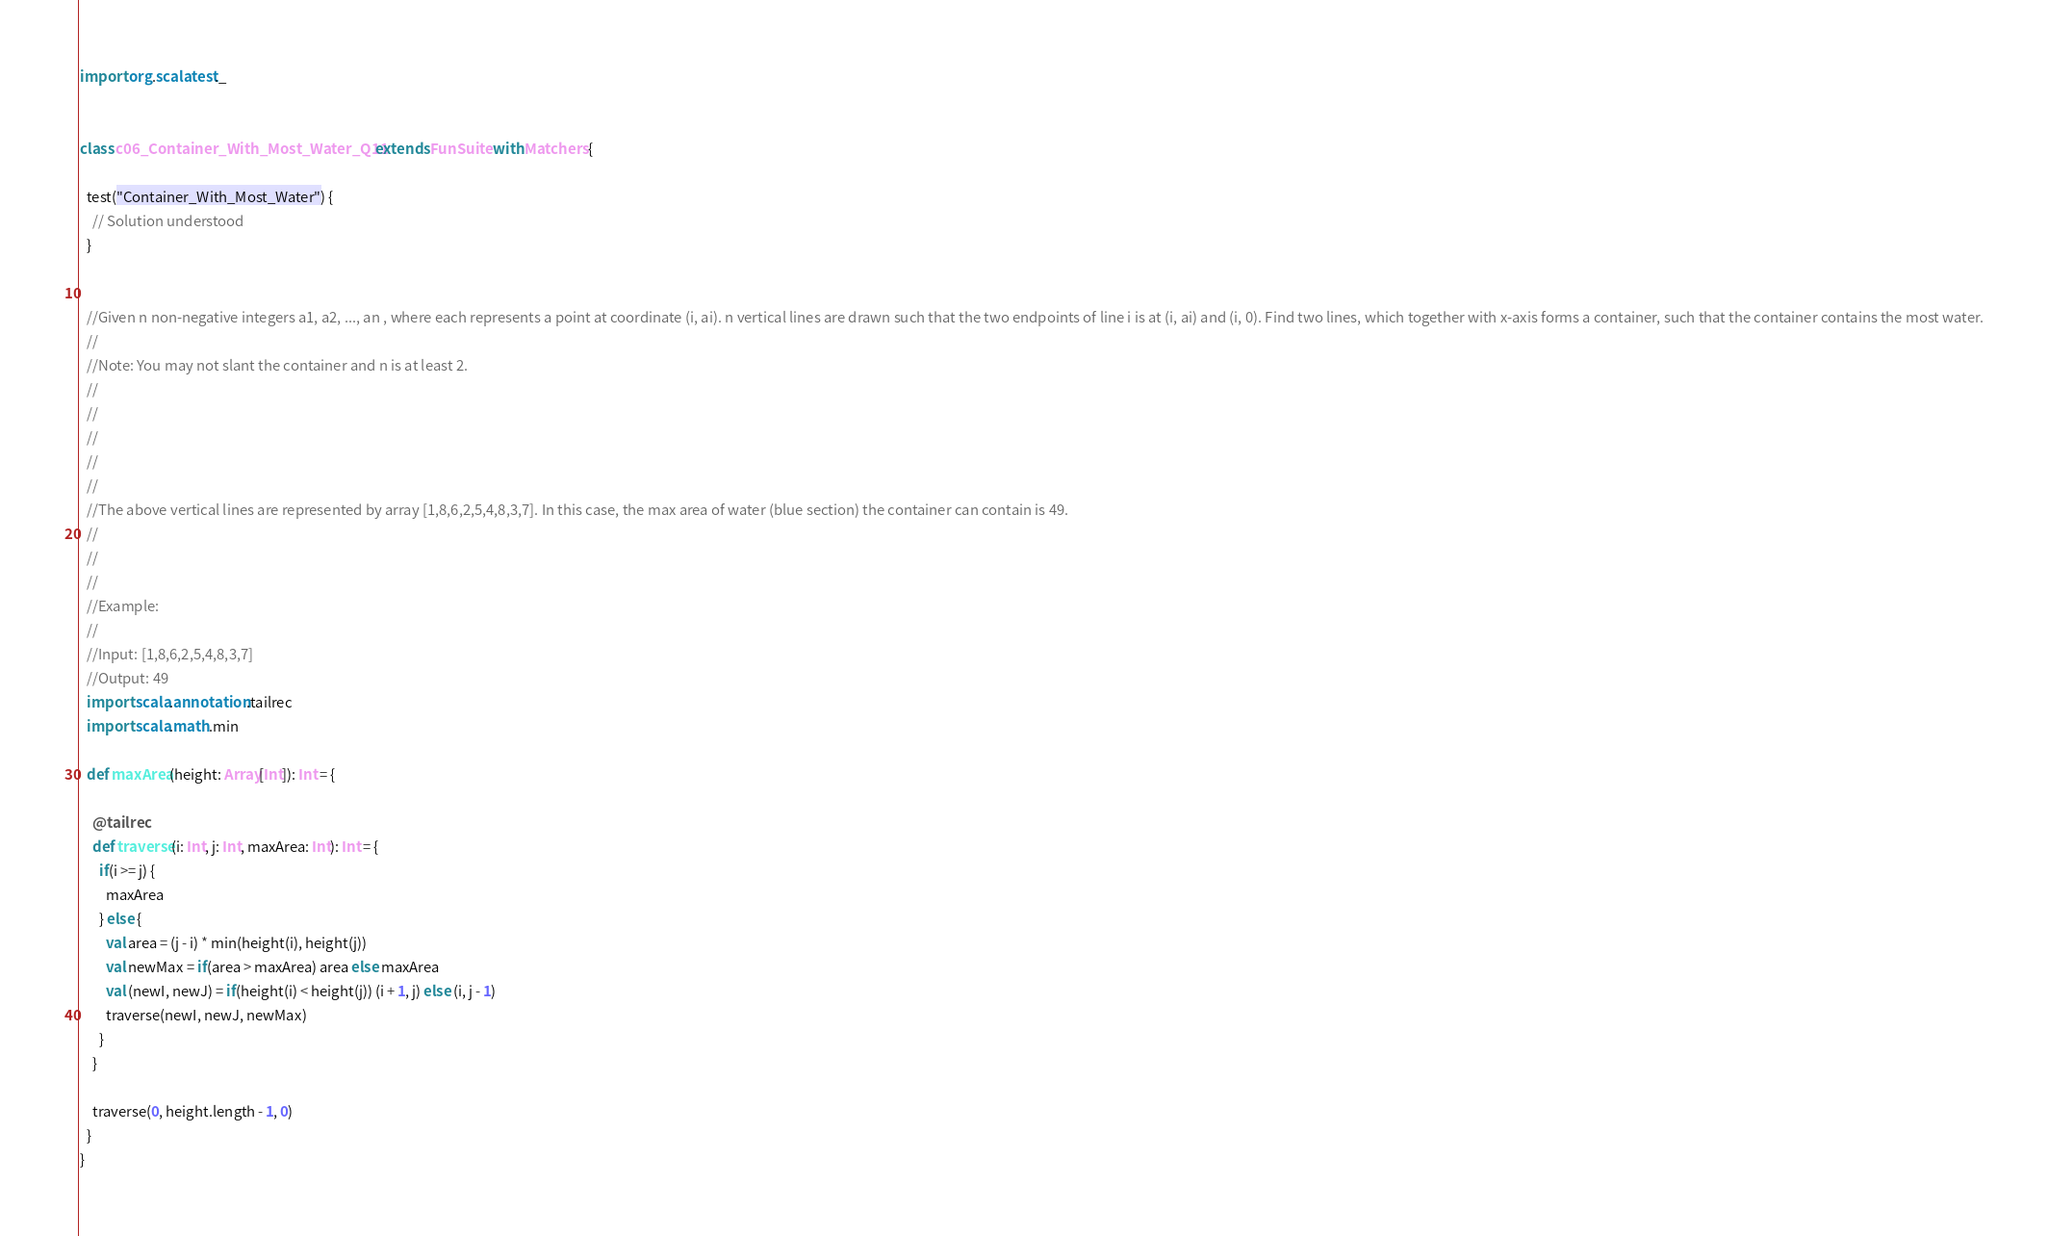<code> <loc_0><loc_0><loc_500><loc_500><_Scala_>
import org.scalatest._


class c06_Container_With_Most_Water_Q11 extends FunSuite with Matchers {

  test("Container_With_Most_Water") {
    // Solution understood
  }


  //Given n non-negative integers a1, a2, ..., an , where each represents a point at coordinate (i, ai). n vertical lines are drawn such that the two endpoints of line i is at (i, ai) and (i, 0). Find two lines, which together with x-axis forms a container, such that the container contains the most water.
  //
  //Note: You may not slant the container and n is at least 2.
  //
  //
  //
  //
  //
  //The above vertical lines are represented by array [1,8,6,2,5,4,8,3,7]. In this case, the max area of water (blue section) the container can contain is 49.
  //
  //
  //
  //Example:
  //
  //Input: [1,8,6,2,5,4,8,3,7]
  //Output: 49
  import scala.annotation.tailrec
  import scala.math.min

  def maxArea(height: Array[Int]): Int = {

    @tailrec
    def traverse(i: Int, j: Int, maxArea: Int): Int = {
      if(i >= j) {
        maxArea
      } else {
        val area = (j - i) * min(height(i), height(j))
        val newMax = if(area > maxArea) area else maxArea
        val (newI, newJ) = if(height(i) < height(j)) (i + 1, j) else (i, j - 1)
        traverse(newI, newJ, newMax)
      }
    }

    traverse(0, height.length - 1, 0)
  }
}</code> 